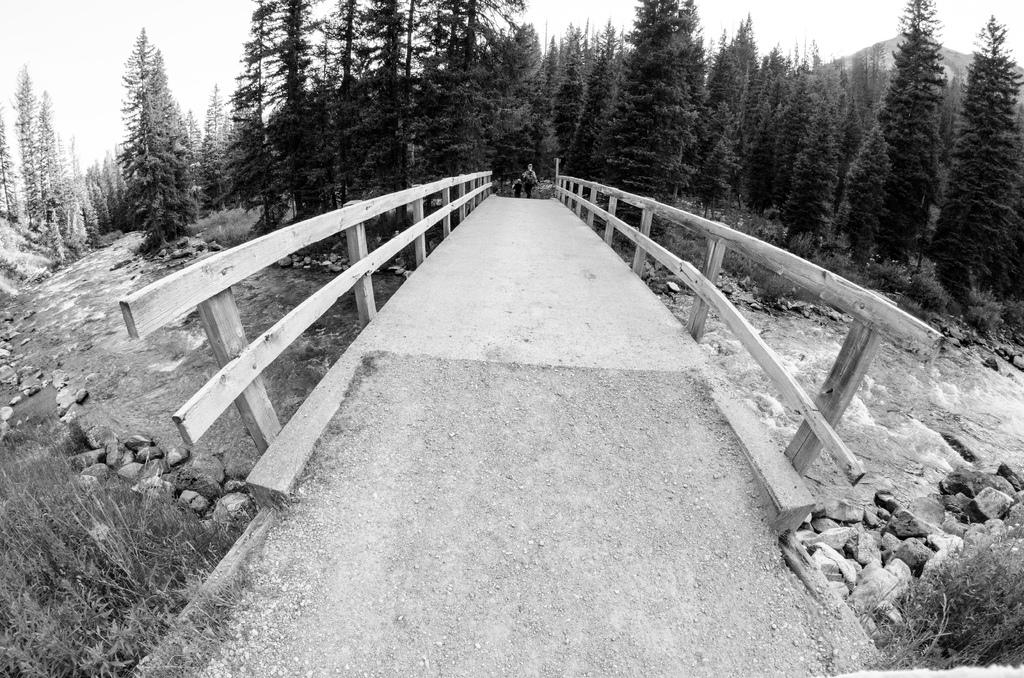What type of body of water is present in the image? There is a water lake in the picture. What structure can be seen crossing the water? There is a bridge in the picture. What natural elements are present near the water? There are rocks and trees in the picture. What activity are the people in the image engaged in? Two people are walking in the picture. What type of mist can be seen surrounding the trees in the image? There is no mist present in the image; it is a clear day with trees visible. What type of clover is growing near the rocks in the image? There is no clover present in the image; it features rocks and trees, but no plants are mentioned. 